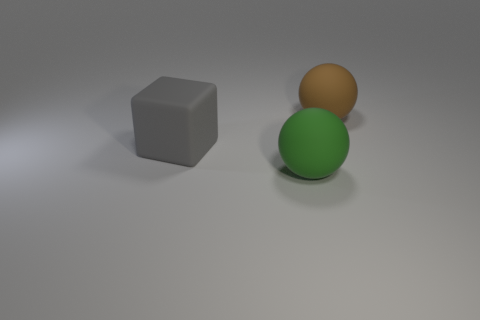What material is the large sphere that is on the left side of the large rubber thing on the right side of the object that is in front of the gray rubber thing?
Your answer should be very brief. Rubber. Are there any other things that have the same shape as the brown rubber object?
Ensure brevity in your answer.  Yes. There is another object that is the same shape as the brown thing; what color is it?
Your response must be concise. Green. Do the ball that is behind the green ball and the big ball that is in front of the big gray thing have the same color?
Your answer should be very brief. No. Are there more large brown rubber objects in front of the brown thing than spheres?
Make the answer very short. No. What number of large rubber objects are to the left of the brown rubber ball and behind the green rubber ball?
Provide a short and direct response. 1. Does the sphere in front of the cube have the same material as the gray thing?
Your answer should be compact. Yes. The green matte thing left of the matte ball right of the big green sphere that is right of the block is what shape?
Your answer should be very brief. Sphere. Are there an equal number of large cubes right of the brown matte ball and gray things in front of the green ball?
Give a very brief answer. Yes. What is the color of the matte block that is the same size as the brown thing?
Your answer should be very brief. Gray. 